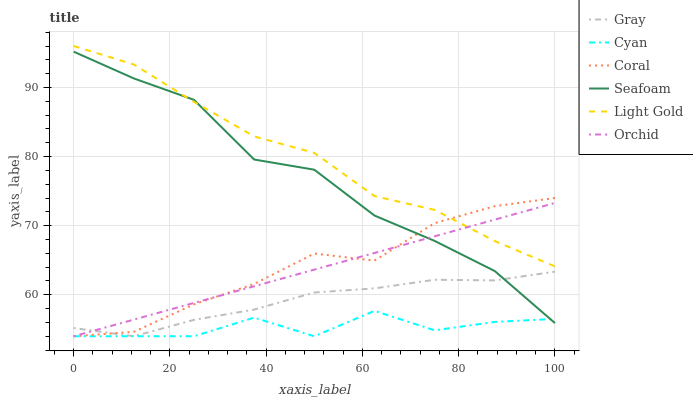Does Cyan have the minimum area under the curve?
Answer yes or no. Yes. Does Light Gold have the maximum area under the curve?
Answer yes or no. Yes. Does Coral have the minimum area under the curve?
Answer yes or no. No. Does Coral have the maximum area under the curve?
Answer yes or no. No. Is Orchid the smoothest?
Answer yes or no. Yes. Is Cyan the roughest?
Answer yes or no. Yes. Is Coral the smoothest?
Answer yes or no. No. Is Coral the roughest?
Answer yes or no. No. Does Gray have the lowest value?
Answer yes or no. Yes. Does Seafoam have the lowest value?
Answer yes or no. No. Does Light Gold have the highest value?
Answer yes or no. Yes. Does Coral have the highest value?
Answer yes or no. No. Is Cyan less than Light Gold?
Answer yes or no. Yes. Is Light Gold greater than Cyan?
Answer yes or no. Yes. Does Light Gold intersect Orchid?
Answer yes or no. Yes. Is Light Gold less than Orchid?
Answer yes or no. No. Is Light Gold greater than Orchid?
Answer yes or no. No. Does Cyan intersect Light Gold?
Answer yes or no. No. 